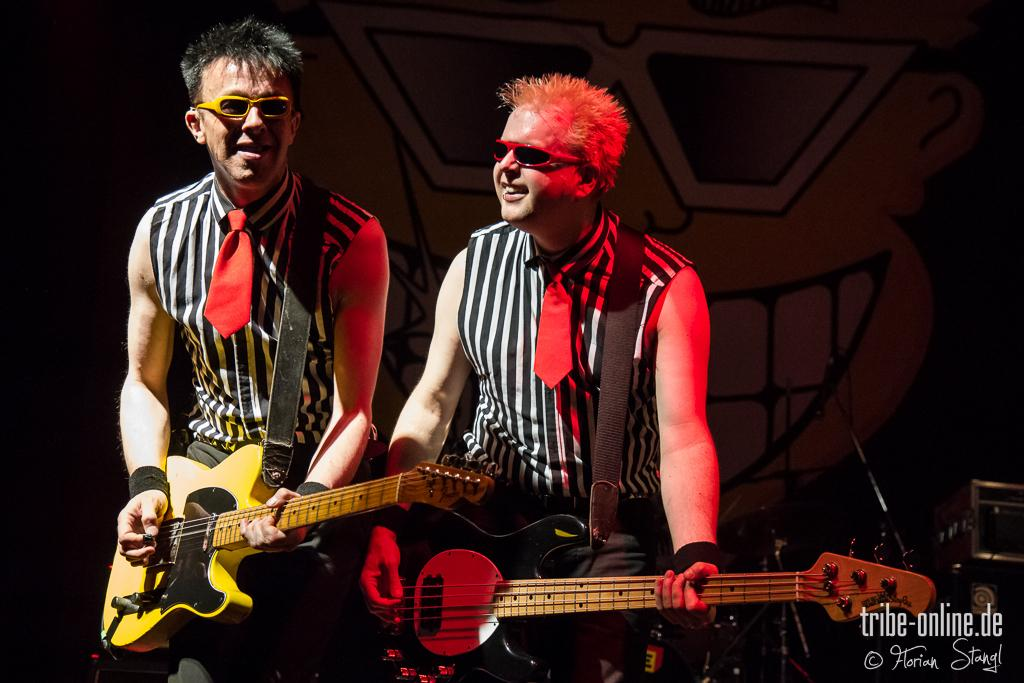How many persons are in the image? There are two persons in the image. What are the persons in the image doing? Both persons are playing guitar. What can be seen on the faces of both persons? Both persons are wearing spectacles. What color is the sweater worn by the brother in the image? There is no mention of a sweater or a brother in the image; the facts only mention two persons playing guitar and wearing spectacles. Can you tell me how many matches are visible in the image? There are no matches present in the image. 